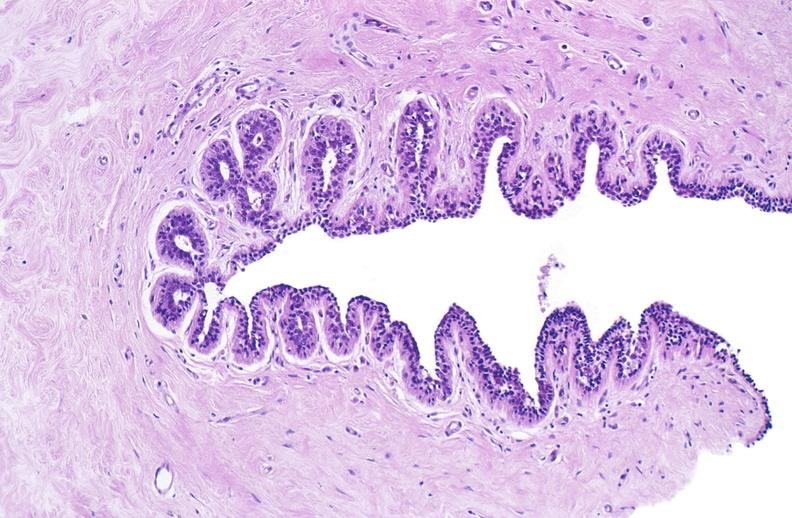what does this image show?
Answer the question using a single word or phrase. Normal breast 